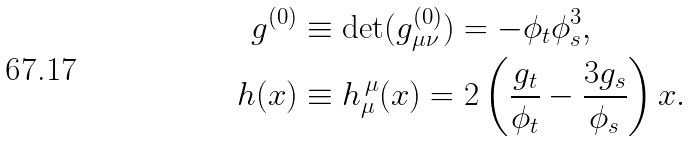Convert formula to latex. <formula><loc_0><loc_0><loc_500><loc_500>g ^ { ( 0 ) } & \equiv \det ( g ^ { ( 0 ) } _ { \mu \nu } ) = - \phi _ { t } \phi _ { s } ^ { 3 } , \\ h ( x ) & \equiv h _ { \mu } ^ { \, \mu } ( x ) = 2 \left ( \frac { g _ { t } } { \phi _ { t } } - \frac { 3 g _ { s } } { \phi _ { s } } \right ) x .</formula> 